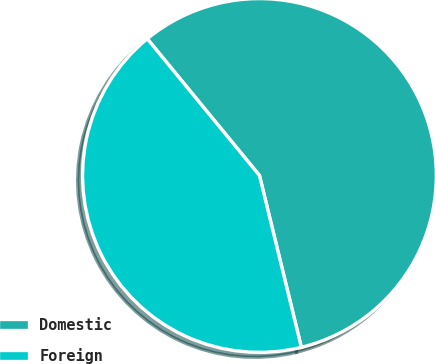Convert chart. <chart><loc_0><loc_0><loc_500><loc_500><pie_chart><fcel>Domestic<fcel>Foreign<nl><fcel>57.13%<fcel>42.87%<nl></chart> 